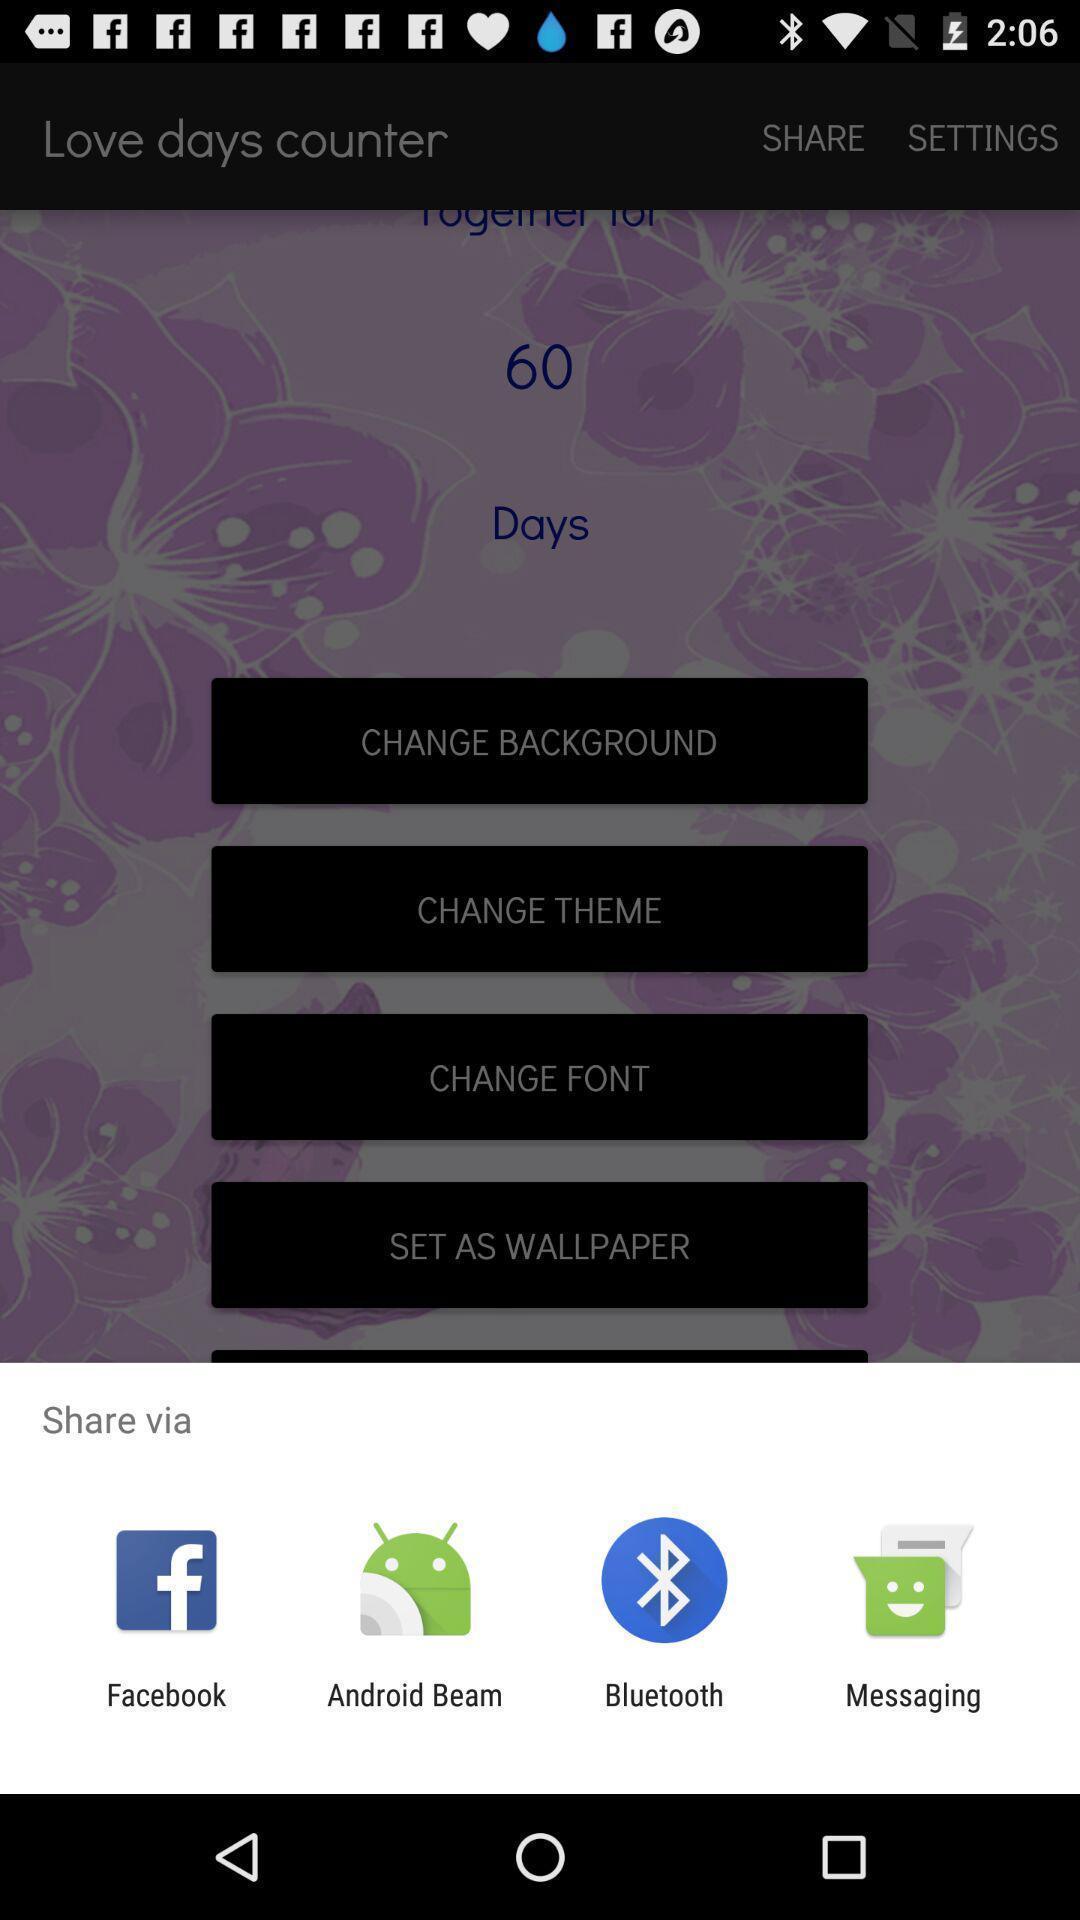Describe the key features of this screenshot. Pop-up shows to share via multiple applications. 